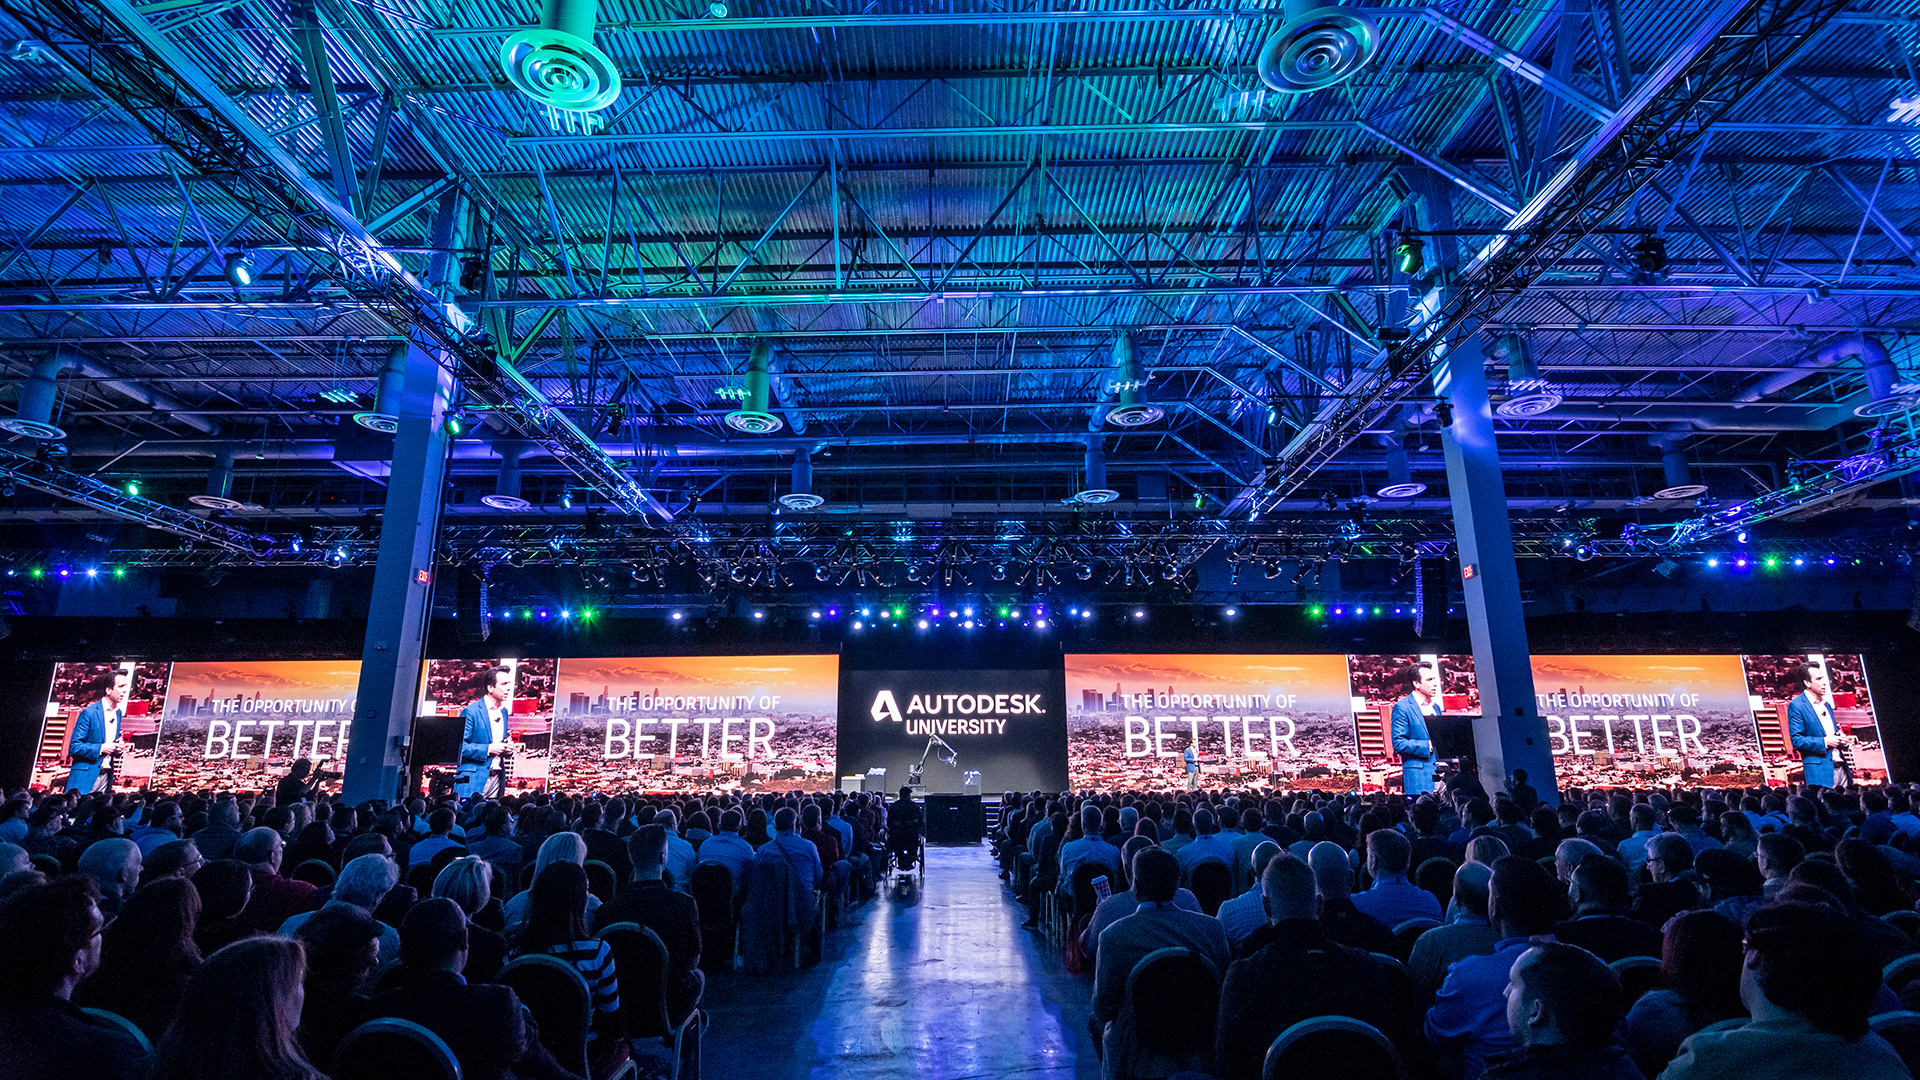Given the setting and the backdrop, what themes or topics do you think might be covered at this event? The event appears to be hosted by Autodesk University, a place where professionals from fields such as architecture, engineering, and entertainment gather. Topics likely covered could include advancements in CAD (computer-aided design) software, innovative construction techniques, sustainable design practices, the future of manufacturing, and the latest in visual effects or animation technologies. Moreover, it could involve practical workshops, hands-on sessions, and keynote speeches from industry leaders, all aimed at fostering knowledge sharing and professional growth. 